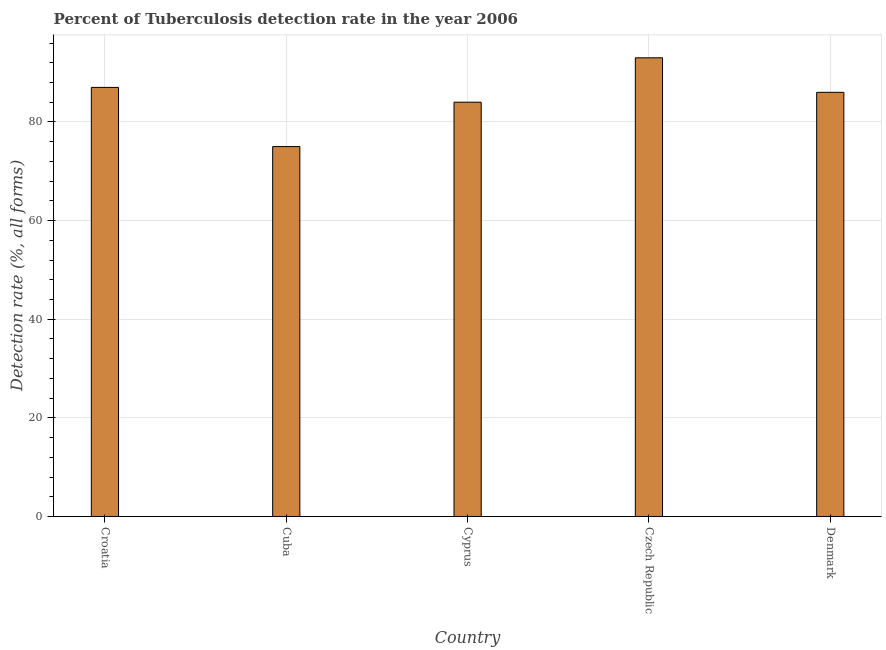Does the graph contain grids?
Give a very brief answer. Yes. What is the title of the graph?
Your answer should be compact. Percent of Tuberculosis detection rate in the year 2006. What is the label or title of the Y-axis?
Make the answer very short. Detection rate (%, all forms). What is the detection rate of tuberculosis in Czech Republic?
Your answer should be compact. 93. Across all countries, what is the maximum detection rate of tuberculosis?
Ensure brevity in your answer.  93. In which country was the detection rate of tuberculosis maximum?
Offer a terse response. Czech Republic. In which country was the detection rate of tuberculosis minimum?
Offer a very short reply. Cuba. What is the sum of the detection rate of tuberculosis?
Your answer should be very brief. 425. In how many countries, is the detection rate of tuberculosis greater than 12 %?
Ensure brevity in your answer.  5. What is the ratio of the detection rate of tuberculosis in Cyprus to that in Denmark?
Provide a succinct answer. 0.98. What is the difference between the highest and the lowest detection rate of tuberculosis?
Give a very brief answer. 18. In how many countries, is the detection rate of tuberculosis greater than the average detection rate of tuberculosis taken over all countries?
Keep it short and to the point. 3. What is the difference between two consecutive major ticks on the Y-axis?
Ensure brevity in your answer.  20. What is the Detection rate (%, all forms) of Croatia?
Provide a succinct answer. 87. What is the Detection rate (%, all forms) of Czech Republic?
Your answer should be very brief. 93. What is the difference between the Detection rate (%, all forms) in Croatia and Cuba?
Make the answer very short. 12. What is the difference between the Detection rate (%, all forms) in Croatia and Denmark?
Your answer should be very brief. 1. What is the difference between the Detection rate (%, all forms) in Cuba and Denmark?
Your answer should be very brief. -11. What is the difference between the Detection rate (%, all forms) in Czech Republic and Denmark?
Make the answer very short. 7. What is the ratio of the Detection rate (%, all forms) in Croatia to that in Cuba?
Keep it short and to the point. 1.16. What is the ratio of the Detection rate (%, all forms) in Croatia to that in Cyprus?
Provide a succinct answer. 1.04. What is the ratio of the Detection rate (%, all forms) in Croatia to that in Czech Republic?
Provide a succinct answer. 0.94. What is the ratio of the Detection rate (%, all forms) in Croatia to that in Denmark?
Give a very brief answer. 1.01. What is the ratio of the Detection rate (%, all forms) in Cuba to that in Cyprus?
Give a very brief answer. 0.89. What is the ratio of the Detection rate (%, all forms) in Cuba to that in Czech Republic?
Offer a very short reply. 0.81. What is the ratio of the Detection rate (%, all forms) in Cuba to that in Denmark?
Keep it short and to the point. 0.87. What is the ratio of the Detection rate (%, all forms) in Cyprus to that in Czech Republic?
Your answer should be compact. 0.9. What is the ratio of the Detection rate (%, all forms) in Cyprus to that in Denmark?
Your answer should be compact. 0.98. What is the ratio of the Detection rate (%, all forms) in Czech Republic to that in Denmark?
Keep it short and to the point. 1.08. 